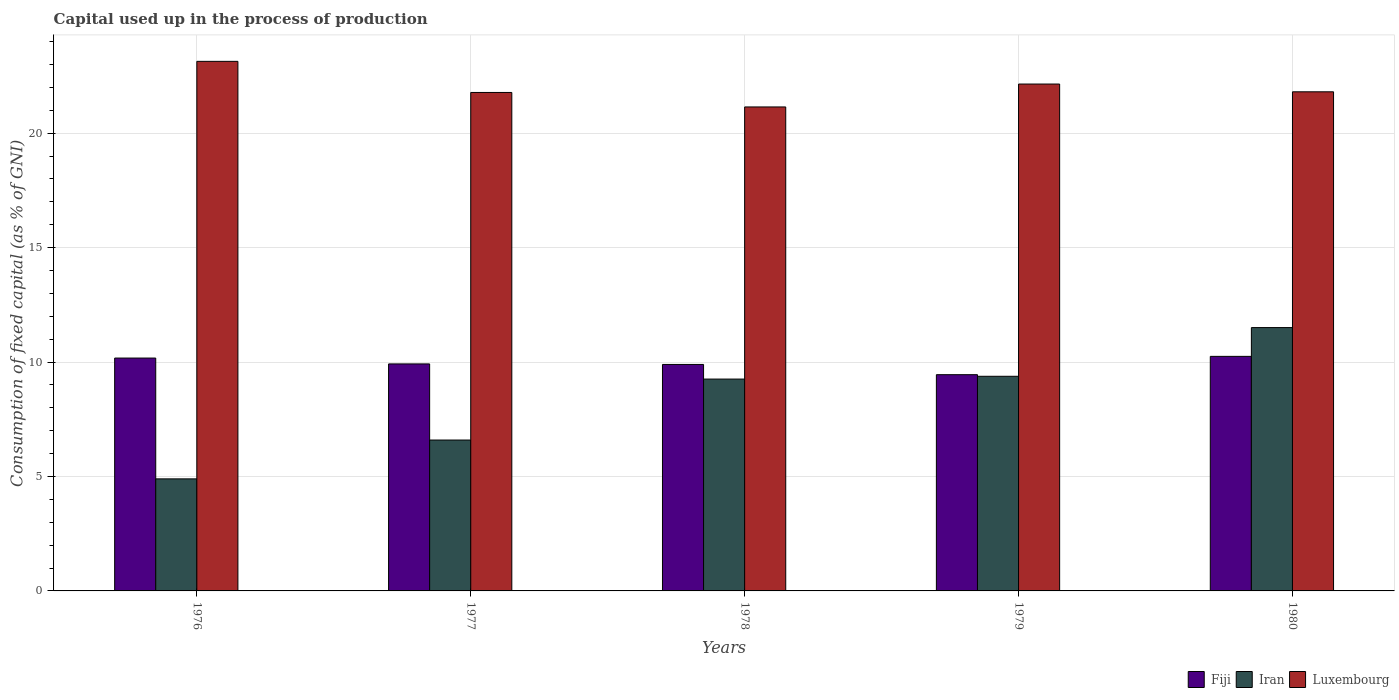How many groups of bars are there?
Your answer should be very brief. 5. Are the number of bars per tick equal to the number of legend labels?
Offer a very short reply. Yes. Are the number of bars on each tick of the X-axis equal?
Your answer should be compact. Yes. How many bars are there on the 2nd tick from the left?
Your answer should be compact. 3. How many bars are there on the 1st tick from the right?
Make the answer very short. 3. What is the label of the 4th group of bars from the left?
Offer a very short reply. 1979. In how many cases, is the number of bars for a given year not equal to the number of legend labels?
Provide a short and direct response. 0. What is the capital used up in the process of production in Iran in 1978?
Your answer should be compact. 9.26. Across all years, what is the maximum capital used up in the process of production in Iran?
Keep it short and to the point. 11.51. Across all years, what is the minimum capital used up in the process of production in Fiji?
Provide a succinct answer. 9.45. In which year was the capital used up in the process of production in Luxembourg minimum?
Your answer should be compact. 1978. What is the total capital used up in the process of production in Luxembourg in the graph?
Make the answer very short. 110.03. What is the difference between the capital used up in the process of production in Luxembourg in 1976 and that in 1978?
Keep it short and to the point. 1.99. What is the difference between the capital used up in the process of production in Luxembourg in 1977 and the capital used up in the process of production in Iran in 1978?
Your answer should be compact. 12.52. What is the average capital used up in the process of production in Luxembourg per year?
Your answer should be very brief. 22.01. In the year 1977, what is the difference between the capital used up in the process of production in Luxembourg and capital used up in the process of production in Iran?
Ensure brevity in your answer.  15.19. What is the ratio of the capital used up in the process of production in Iran in 1978 to that in 1979?
Make the answer very short. 0.99. Is the capital used up in the process of production in Fiji in 1978 less than that in 1980?
Your answer should be very brief. Yes. Is the difference between the capital used up in the process of production in Luxembourg in 1979 and 1980 greater than the difference between the capital used up in the process of production in Iran in 1979 and 1980?
Make the answer very short. Yes. What is the difference between the highest and the second highest capital used up in the process of production in Luxembourg?
Provide a short and direct response. 0.99. What is the difference between the highest and the lowest capital used up in the process of production in Luxembourg?
Make the answer very short. 1.99. In how many years, is the capital used up in the process of production in Iran greater than the average capital used up in the process of production in Iran taken over all years?
Give a very brief answer. 3. What does the 3rd bar from the left in 1976 represents?
Provide a succinct answer. Luxembourg. What does the 1st bar from the right in 1977 represents?
Your answer should be compact. Luxembourg. Are all the bars in the graph horizontal?
Give a very brief answer. No. How many years are there in the graph?
Provide a succinct answer. 5. What is the difference between two consecutive major ticks on the Y-axis?
Your response must be concise. 5. Are the values on the major ticks of Y-axis written in scientific E-notation?
Keep it short and to the point. No. Does the graph contain any zero values?
Make the answer very short. No. How many legend labels are there?
Give a very brief answer. 3. How are the legend labels stacked?
Make the answer very short. Horizontal. What is the title of the graph?
Ensure brevity in your answer.  Capital used up in the process of production. Does "St. Kitts and Nevis" appear as one of the legend labels in the graph?
Offer a very short reply. No. What is the label or title of the X-axis?
Ensure brevity in your answer.  Years. What is the label or title of the Y-axis?
Provide a succinct answer. Consumption of fixed capital (as % of GNI). What is the Consumption of fixed capital (as % of GNI) of Fiji in 1976?
Provide a succinct answer. 10.18. What is the Consumption of fixed capital (as % of GNI) of Iran in 1976?
Your answer should be compact. 4.9. What is the Consumption of fixed capital (as % of GNI) in Luxembourg in 1976?
Provide a short and direct response. 23.14. What is the Consumption of fixed capital (as % of GNI) in Fiji in 1977?
Provide a short and direct response. 9.92. What is the Consumption of fixed capital (as % of GNI) in Iran in 1977?
Provide a short and direct response. 6.59. What is the Consumption of fixed capital (as % of GNI) of Luxembourg in 1977?
Provide a succinct answer. 21.78. What is the Consumption of fixed capital (as % of GNI) in Fiji in 1978?
Keep it short and to the point. 9.9. What is the Consumption of fixed capital (as % of GNI) in Iran in 1978?
Provide a short and direct response. 9.26. What is the Consumption of fixed capital (as % of GNI) in Luxembourg in 1978?
Offer a very short reply. 21.15. What is the Consumption of fixed capital (as % of GNI) in Fiji in 1979?
Make the answer very short. 9.45. What is the Consumption of fixed capital (as % of GNI) of Iran in 1979?
Your answer should be compact. 9.38. What is the Consumption of fixed capital (as % of GNI) of Luxembourg in 1979?
Offer a very short reply. 22.15. What is the Consumption of fixed capital (as % of GNI) in Fiji in 1980?
Give a very brief answer. 10.25. What is the Consumption of fixed capital (as % of GNI) in Iran in 1980?
Your answer should be compact. 11.51. What is the Consumption of fixed capital (as % of GNI) in Luxembourg in 1980?
Provide a short and direct response. 21.81. Across all years, what is the maximum Consumption of fixed capital (as % of GNI) of Fiji?
Your response must be concise. 10.25. Across all years, what is the maximum Consumption of fixed capital (as % of GNI) in Iran?
Make the answer very short. 11.51. Across all years, what is the maximum Consumption of fixed capital (as % of GNI) of Luxembourg?
Your answer should be very brief. 23.14. Across all years, what is the minimum Consumption of fixed capital (as % of GNI) of Fiji?
Give a very brief answer. 9.45. Across all years, what is the minimum Consumption of fixed capital (as % of GNI) of Iran?
Give a very brief answer. 4.9. Across all years, what is the minimum Consumption of fixed capital (as % of GNI) in Luxembourg?
Ensure brevity in your answer.  21.15. What is the total Consumption of fixed capital (as % of GNI) of Fiji in the graph?
Provide a succinct answer. 49.69. What is the total Consumption of fixed capital (as % of GNI) in Iran in the graph?
Your answer should be very brief. 41.63. What is the total Consumption of fixed capital (as % of GNI) of Luxembourg in the graph?
Offer a terse response. 110.03. What is the difference between the Consumption of fixed capital (as % of GNI) in Fiji in 1976 and that in 1977?
Provide a succinct answer. 0.26. What is the difference between the Consumption of fixed capital (as % of GNI) of Iran in 1976 and that in 1977?
Your answer should be very brief. -1.7. What is the difference between the Consumption of fixed capital (as % of GNI) in Luxembourg in 1976 and that in 1977?
Offer a very short reply. 1.36. What is the difference between the Consumption of fixed capital (as % of GNI) of Fiji in 1976 and that in 1978?
Offer a very short reply. 0.28. What is the difference between the Consumption of fixed capital (as % of GNI) of Iran in 1976 and that in 1978?
Ensure brevity in your answer.  -4.36. What is the difference between the Consumption of fixed capital (as % of GNI) in Luxembourg in 1976 and that in 1978?
Offer a very short reply. 1.99. What is the difference between the Consumption of fixed capital (as % of GNI) in Fiji in 1976 and that in 1979?
Make the answer very short. 0.73. What is the difference between the Consumption of fixed capital (as % of GNI) in Iran in 1976 and that in 1979?
Your answer should be compact. -4.48. What is the difference between the Consumption of fixed capital (as % of GNI) in Luxembourg in 1976 and that in 1979?
Provide a short and direct response. 0.99. What is the difference between the Consumption of fixed capital (as % of GNI) in Fiji in 1976 and that in 1980?
Make the answer very short. -0.07. What is the difference between the Consumption of fixed capital (as % of GNI) in Iran in 1976 and that in 1980?
Offer a very short reply. -6.61. What is the difference between the Consumption of fixed capital (as % of GNI) of Luxembourg in 1976 and that in 1980?
Provide a succinct answer. 1.33. What is the difference between the Consumption of fixed capital (as % of GNI) in Fiji in 1977 and that in 1978?
Keep it short and to the point. 0.02. What is the difference between the Consumption of fixed capital (as % of GNI) in Iran in 1977 and that in 1978?
Offer a very short reply. -2.66. What is the difference between the Consumption of fixed capital (as % of GNI) in Luxembourg in 1977 and that in 1978?
Provide a short and direct response. 0.63. What is the difference between the Consumption of fixed capital (as % of GNI) of Fiji in 1977 and that in 1979?
Ensure brevity in your answer.  0.47. What is the difference between the Consumption of fixed capital (as % of GNI) of Iran in 1977 and that in 1979?
Offer a very short reply. -2.79. What is the difference between the Consumption of fixed capital (as % of GNI) in Luxembourg in 1977 and that in 1979?
Your answer should be compact. -0.37. What is the difference between the Consumption of fixed capital (as % of GNI) in Fiji in 1977 and that in 1980?
Provide a short and direct response. -0.33. What is the difference between the Consumption of fixed capital (as % of GNI) in Iran in 1977 and that in 1980?
Provide a short and direct response. -4.91. What is the difference between the Consumption of fixed capital (as % of GNI) of Luxembourg in 1977 and that in 1980?
Provide a short and direct response. -0.03. What is the difference between the Consumption of fixed capital (as % of GNI) of Fiji in 1978 and that in 1979?
Your answer should be very brief. 0.45. What is the difference between the Consumption of fixed capital (as % of GNI) in Iran in 1978 and that in 1979?
Offer a very short reply. -0.12. What is the difference between the Consumption of fixed capital (as % of GNI) of Luxembourg in 1978 and that in 1979?
Your answer should be very brief. -1. What is the difference between the Consumption of fixed capital (as % of GNI) of Fiji in 1978 and that in 1980?
Offer a terse response. -0.35. What is the difference between the Consumption of fixed capital (as % of GNI) of Iran in 1978 and that in 1980?
Your response must be concise. -2.25. What is the difference between the Consumption of fixed capital (as % of GNI) of Luxembourg in 1978 and that in 1980?
Offer a terse response. -0.66. What is the difference between the Consumption of fixed capital (as % of GNI) of Fiji in 1979 and that in 1980?
Give a very brief answer. -0.8. What is the difference between the Consumption of fixed capital (as % of GNI) in Iran in 1979 and that in 1980?
Ensure brevity in your answer.  -2.13. What is the difference between the Consumption of fixed capital (as % of GNI) in Luxembourg in 1979 and that in 1980?
Your answer should be compact. 0.34. What is the difference between the Consumption of fixed capital (as % of GNI) in Fiji in 1976 and the Consumption of fixed capital (as % of GNI) in Iran in 1977?
Offer a terse response. 3.58. What is the difference between the Consumption of fixed capital (as % of GNI) of Fiji in 1976 and the Consumption of fixed capital (as % of GNI) of Luxembourg in 1977?
Offer a very short reply. -11.61. What is the difference between the Consumption of fixed capital (as % of GNI) in Iran in 1976 and the Consumption of fixed capital (as % of GNI) in Luxembourg in 1977?
Make the answer very short. -16.88. What is the difference between the Consumption of fixed capital (as % of GNI) of Fiji in 1976 and the Consumption of fixed capital (as % of GNI) of Iran in 1978?
Offer a terse response. 0.92. What is the difference between the Consumption of fixed capital (as % of GNI) in Fiji in 1976 and the Consumption of fixed capital (as % of GNI) in Luxembourg in 1978?
Your response must be concise. -10.97. What is the difference between the Consumption of fixed capital (as % of GNI) in Iran in 1976 and the Consumption of fixed capital (as % of GNI) in Luxembourg in 1978?
Your answer should be compact. -16.25. What is the difference between the Consumption of fixed capital (as % of GNI) in Fiji in 1976 and the Consumption of fixed capital (as % of GNI) in Iran in 1979?
Provide a succinct answer. 0.8. What is the difference between the Consumption of fixed capital (as % of GNI) in Fiji in 1976 and the Consumption of fixed capital (as % of GNI) in Luxembourg in 1979?
Provide a short and direct response. -11.97. What is the difference between the Consumption of fixed capital (as % of GNI) of Iran in 1976 and the Consumption of fixed capital (as % of GNI) of Luxembourg in 1979?
Your answer should be compact. -17.25. What is the difference between the Consumption of fixed capital (as % of GNI) of Fiji in 1976 and the Consumption of fixed capital (as % of GNI) of Iran in 1980?
Ensure brevity in your answer.  -1.33. What is the difference between the Consumption of fixed capital (as % of GNI) in Fiji in 1976 and the Consumption of fixed capital (as % of GNI) in Luxembourg in 1980?
Offer a very short reply. -11.63. What is the difference between the Consumption of fixed capital (as % of GNI) in Iran in 1976 and the Consumption of fixed capital (as % of GNI) in Luxembourg in 1980?
Provide a succinct answer. -16.91. What is the difference between the Consumption of fixed capital (as % of GNI) in Fiji in 1977 and the Consumption of fixed capital (as % of GNI) in Iran in 1978?
Offer a terse response. 0.66. What is the difference between the Consumption of fixed capital (as % of GNI) in Fiji in 1977 and the Consumption of fixed capital (as % of GNI) in Luxembourg in 1978?
Keep it short and to the point. -11.23. What is the difference between the Consumption of fixed capital (as % of GNI) of Iran in 1977 and the Consumption of fixed capital (as % of GNI) of Luxembourg in 1978?
Provide a succinct answer. -14.55. What is the difference between the Consumption of fixed capital (as % of GNI) in Fiji in 1977 and the Consumption of fixed capital (as % of GNI) in Iran in 1979?
Offer a terse response. 0.54. What is the difference between the Consumption of fixed capital (as % of GNI) in Fiji in 1977 and the Consumption of fixed capital (as % of GNI) in Luxembourg in 1979?
Offer a very short reply. -12.23. What is the difference between the Consumption of fixed capital (as % of GNI) of Iran in 1977 and the Consumption of fixed capital (as % of GNI) of Luxembourg in 1979?
Make the answer very short. -15.56. What is the difference between the Consumption of fixed capital (as % of GNI) of Fiji in 1977 and the Consumption of fixed capital (as % of GNI) of Iran in 1980?
Keep it short and to the point. -1.59. What is the difference between the Consumption of fixed capital (as % of GNI) in Fiji in 1977 and the Consumption of fixed capital (as % of GNI) in Luxembourg in 1980?
Your answer should be compact. -11.89. What is the difference between the Consumption of fixed capital (as % of GNI) of Iran in 1977 and the Consumption of fixed capital (as % of GNI) of Luxembourg in 1980?
Keep it short and to the point. -15.22. What is the difference between the Consumption of fixed capital (as % of GNI) in Fiji in 1978 and the Consumption of fixed capital (as % of GNI) in Iran in 1979?
Make the answer very short. 0.52. What is the difference between the Consumption of fixed capital (as % of GNI) in Fiji in 1978 and the Consumption of fixed capital (as % of GNI) in Luxembourg in 1979?
Offer a very short reply. -12.25. What is the difference between the Consumption of fixed capital (as % of GNI) of Iran in 1978 and the Consumption of fixed capital (as % of GNI) of Luxembourg in 1979?
Offer a terse response. -12.89. What is the difference between the Consumption of fixed capital (as % of GNI) of Fiji in 1978 and the Consumption of fixed capital (as % of GNI) of Iran in 1980?
Your response must be concise. -1.61. What is the difference between the Consumption of fixed capital (as % of GNI) of Fiji in 1978 and the Consumption of fixed capital (as % of GNI) of Luxembourg in 1980?
Your answer should be very brief. -11.91. What is the difference between the Consumption of fixed capital (as % of GNI) in Iran in 1978 and the Consumption of fixed capital (as % of GNI) in Luxembourg in 1980?
Keep it short and to the point. -12.55. What is the difference between the Consumption of fixed capital (as % of GNI) of Fiji in 1979 and the Consumption of fixed capital (as % of GNI) of Iran in 1980?
Keep it short and to the point. -2.06. What is the difference between the Consumption of fixed capital (as % of GNI) in Fiji in 1979 and the Consumption of fixed capital (as % of GNI) in Luxembourg in 1980?
Give a very brief answer. -12.36. What is the difference between the Consumption of fixed capital (as % of GNI) of Iran in 1979 and the Consumption of fixed capital (as % of GNI) of Luxembourg in 1980?
Make the answer very short. -12.43. What is the average Consumption of fixed capital (as % of GNI) in Fiji per year?
Your answer should be very brief. 9.94. What is the average Consumption of fixed capital (as % of GNI) of Iran per year?
Your response must be concise. 8.33. What is the average Consumption of fixed capital (as % of GNI) of Luxembourg per year?
Provide a short and direct response. 22.01. In the year 1976, what is the difference between the Consumption of fixed capital (as % of GNI) of Fiji and Consumption of fixed capital (as % of GNI) of Iran?
Ensure brevity in your answer.  5.28. In the year 1976, what is the difference between the Consumption of fixed capital (as % of GNI) in Fiji and Consumption of fixed capital (as % of GNI) in Luxembourg?
Your response must be concise. -12.96. In the year 1976, what is the difference between the Consumption of fixed capital (as % of GNI) of Iran and Consumption of fixed capital (as % of GNI) of Luxembourg?
Your answer should be very brief. -18.24. In the year 1977, what is the difference between the Consumption of fixed capital (as % of GNI) in Fiji and Consumption of fixed capital (as % of GNI) in Iran?
Offer a very short reply. 3.33. In the year 1977, what is the difference between the Consumption of fixed capital (as % of GNI) in Fiji and Consumption of fixed capital (as % of GNI) in Luxembourg?
Provide a succinct answer. -11.86. In the year 1977, what is the difference between the Consumption of fixed capital (as % of GNI) in Iran and Consumption of fixed capital (as % of GNI) in Luxembourg?
Give a very brief answer. -15.19. In the year 1978, what is the difference between the Consumption of fixed capital (as % of GNI) in Fiji and Consumption of fixed capital (as % of GNI) in Iran?
Offer a very short reply. 0.64. In the year 1978, what is the difference between the Consumption of fixed capital (as % of GNI) of Fiji and Consumption of fixed capital (as % of GNI) of Luxembourg?
Give a very brief answer. -11.25. In the year 1978, what is the difference between the Consumption of fixed capital (as % of GNI) in Iran and Consumption of fixed capital (as % of GNI) in Luxembourg?
Your answer should be very brief. -11.89. In the year 1979, what is the difference between the Consumption of fixed capital (as % of GNI) of Fiji and Consumption of fixed capital (as % of GNI) of Iran?
Keep it short and to the point. 0.07. In the year 1979, what is the difference between the Consumption of fixed capital (as % of GNI) in Fiji and Consumption of fixed capital (as % of GNI) in Luxembourg?
Provide a succinct answer. -12.7. In the year 1979, what is the difference between the Consumption of fixed capital (as % of GNI) in Iran and Consumption of fixed capital (as % of GNI) in Luxembourg?
Provide a short and direct response. -12.77. In the year 1980, what is the difference between the Consumption of fixed capital (as % of GNI) of Fiji and Consumption of fixed capital (as % of GNI) of Iran?
Provide a succinct answer. -1.26. In the year 1980, what is the difference between the Consumption of fixed capital (as % of GNI) of Fiji and Consumption of fixed capital (as % of GNI) of Luxembourg?
Provide a short and direct response. -11.56. In the year 1980, what is the difference between the Consumption of fixed capital (as % of GNI) of Iran and Consumption of fixed capital (as % of GNI) of Luxembourg?
Give a very brief answer. -10.3. What is the ratio of the Consumption of fixed capital (as % of GNI) of Fiji in 1976 to that in 1977?
Offer a terse response. 1.03. What is the ratio of the Consumption of fixed capital (as % of GNI) of Iran in 1976 to that in 1977?
Your response must be concise. 0.74. What is the ratio of the Consumption of fixed capital (as % of GNI) of Luxembourg in 1976 to that in 1977?
Offer a terse response. 1.06. What is the ratio of the Consumption of fixed capital (as % of GNI) in Fiji in 1976 to that in 1978?
Your answer should be compact. 1.03. What is the ratio of the Consumption of fixed capital (as % of GNI) in Iran in 1976 to that in 1978?
Offer a terse response. 0.53. What is the ratio of the Consumption of fixed capital (as % of GNI) of Luxembourg in 1976 to that in 1978?
Your response must be concise. 1.09. What is the ratio of the Consumption of fixed capital (as % of GNI) of Iran in 1976 to that in 1979?
Offer a terse response. 0.52. What is the ratio of the Consumption of fixed capital (as % of GNI) of Luxembourg in 1976 to that in 1979?
Offer a very short reply. 1.04. What is the ratio of the Consumption of fixed capital (as % of GNI) of Fiji in 1976 to that in 1980?
Ensure brevity in your answer.  0.99. What is the ratio of the Consumption of fixed capital (as % of GNI) in Iran in 1976 to that in 1980?
Your answer should be very brief. 0.43. What is the ratio of the Consumption of fixed capital (as % of GNI) of Luxembourg in 1976 to that in 1980?
Your response must be concise. 1.06. What is the ratio of the Consumption of fixed capital (as % of GNI) of Fiji in 1977 to that in 1978?
Keep it short and to the point. 1. What is the ratio of the Consumption of fixed capital (as % of GNI) in Iran in 1977 to that in 1978?
Ensure brevity in your answer.  0.71. What is the ratio of the Consumption of fixed capital (as % of GNI) of Luxembourg in 1977 to that in 1978?
Provide a succinct answer. 1.03. What is the ratio of the Consumption of fixed capital (as % of GNI) in Fiji in 1977 to that in 1979?
Offer a terse response. 1.05. What is the ratio of the Consumption of fixed capital (as % of GNI) in Iran in 1977 to that in 1979?
Offer a terse response. 0.7. What is the ratio of the Consumption of fixed capital (as % of GNI) in Luxembourg in 1977 to that in 1979?
Your answer should be very brief. 0.98. What is the ratio of the Consumption of fixed capital (as % of GNI) in Fiji in 1977 to that in 1980?
Give a very brief answer. 0.97. What is the ratio of the Consumption of fixed capital (as % of GNI) in Iran in 1977 to that in 1980?
Your answer should be compact. 0.57. What is the ratio of the Consumption of fixed capital (as % of GNI) in Fiji in 1978 to that in 1979?
Your answer should be compact. 1.05. What is the ratio of the Consumption of fixed capital (as % of GNI) of Iran in 1978 to that in 1979?
Offer a very short reply. 0.99. What is the ratio of the Consumption of fixed capital (as % of GNI) in Luxembourg in 1978 to that in 1979?
Ensure brevity in your answer.  0.95. What is the ratio of the Consumption of fixed capital (as % of GNI) in Fiji in 1978 to that in 1980?
Ensure brevity in your answer.  0.97. What is the ratio of the Consumption of fixed capital (as % of GNI) of Iran in 1978 to that in 1980?
Ensure brevity in your answer.  0.8. What is the ratio of the Consumption of fixed capital (as % of GNI) of Luxembourg in 1978 to that in 1980?
Offer a very short reply. 0.97. What is the ratio of the Consumption of fixed capital (as % of GNI) of Fiji in 1979 to that in 1980?
Your answer should be compact. 0.92. What is the ratio of the Consumption of fixed capital (as % of GNI) in Iran in 1979 to that in 1980?
Make the answer very short. 0.82. What is the ratio of the Consumption of fixed capital (as % of GNI) in Luxembourg in 1979 to that in 1980?
Provide a succinct answer. 1.02. What is the difference between the highest and the second highest Consumption of fixed capital (as % of GNI) in Fiji?
Make the answer very short. 0.07. What is the difference between the highest and the second highest Consumption of fixed capital (as % of GNI) in Iran?
Offer a terse response. 2.13. What is the difference between the highest and the lowest Consumption of fixed capital (as % of GNI) of Fiji?
Ensure brevity in your answer.  0.8. What is the difference between the highest and the lowest Consumption of fixed capital (as % of GNI) in Iran?
Provide a short and direct response. 6.61. What is the difference between the highest and the lowest Consumption of fixed capital (as % of GNI) in Luxembourg?
Your answer should be compact. 1.99. 